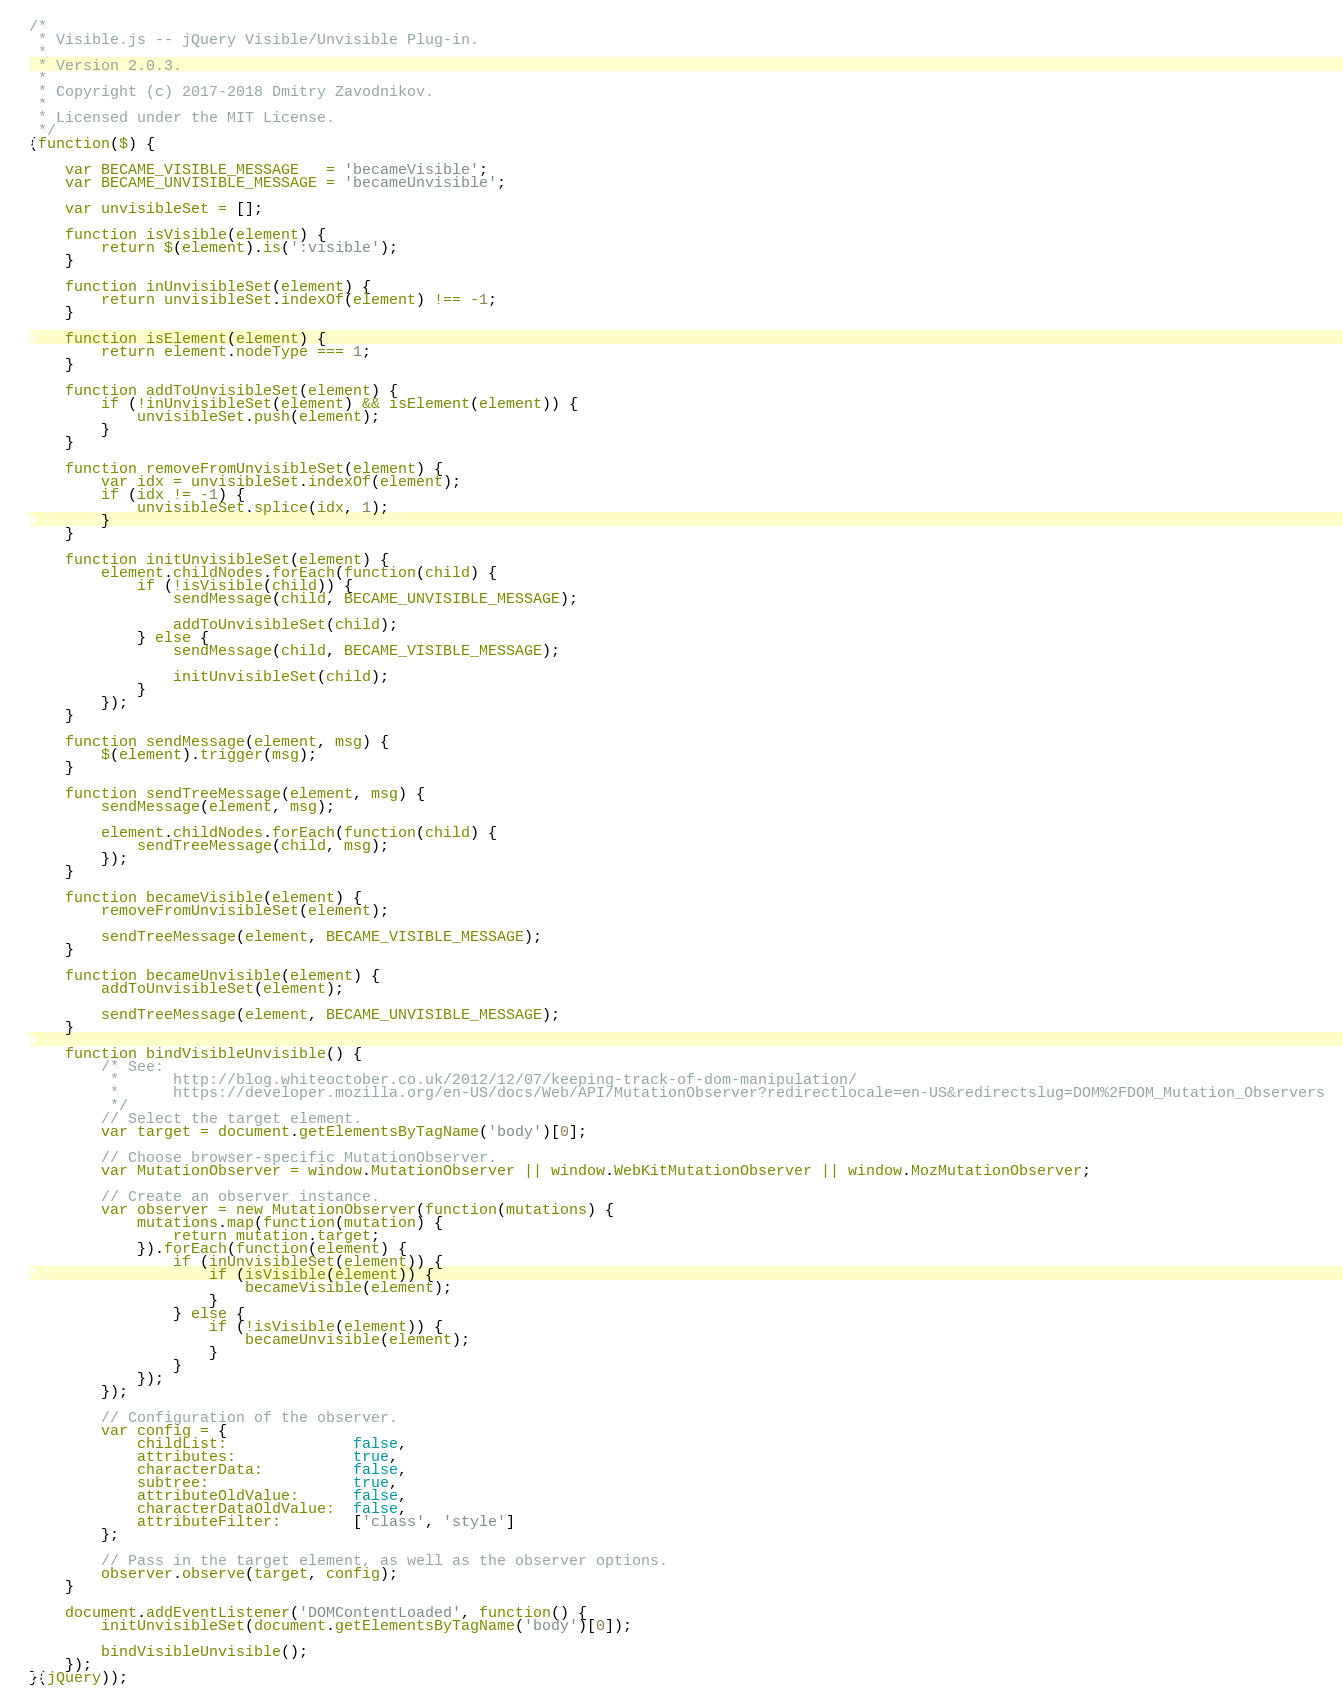<code> <loc_0><loc_0><loc_500><loc_500><_JavaScript_>/*
 * Visible.js -- jQuery Visible/Unvisible Plug-in.
 *
 * Version 2.0.3.
 *
 * Copyright (c) 2017-2018 Dmitry Zavodnikov.
 *
 * Licensed under the MIT License.
 */
(function($) {

    var BECAME_VISIBLE_MESSAGE   = 'becameVisible';
    var BECAME_UNVISIBLE_MESSAGE = 'becameUnvisible';

    var unvisibleSet = [];

    function isVisible(element) {
        return $(element).is(':visible');
    }

    function inUnvisibleSet(element) {
        return unvisibleSet.indexOf(element) !== -1;
    }

    function isElement(element) {
        return element.nodeType === 1;
    }

    function addToUnvisibleSet(element) {
        if (!inUnvisibleSet(element) && isElement(element)) {
            unvisibleSet.push(element);
        }
    }

    function removeFromUnvisibleSet(element) {
        var idx = unvisibleSet.indexOf(element);
        if (idx != -1) {
            unvisibleSet.splice(idx, 1);
        }
    }

    function initUnvisibleSet(element) {
        element.childNodes.forEach(function(child) {
            if (!isVisible(child)) {
                sendMessage(child, BECAME_UNVISIBLE_MESSAGE);

                addToUnvisibleSet(child);
            } else {
                sendMessage(child, BECAME_VISIBLE_MESSAGE);

                initUnvisibleSet(child);
            }
        });
    }

    function sendMessage(element, msg) {
        $(element).trigger(msg);
    }

    function sendTreeMessage(element, msg) {
        sendMessage(element, msg);

        element.childNodes.forEach(function(child) {
            sendTreeMessage(child, msg);
        });
    }

    function becameVisible(element) {
        removeFromUnvisibleSet(element);

        sendTreeMessage(element, BECAME_VISIBLE_MESSAGE);
    }

    function becameUnvisible(element) {
        addToUnvisibleSet(element);

        sendTreeMessage(element, BECAME_UNVISIBLE_MESSAGE);
    }

    function bindVisibleUnvisible() {
        /* See:
         *      http://blog.whiteoctober.co.uk/2012/12/07/keeping-track-of-dom-manipulation/
         *      https://developer.mozilla.org/en-US/docs/Web/API/MutationObserver?redirectlocale=en-US&redirectslug=DOM%2FDOM_Mutation_Observers
         */
        // Select the target element.
        var target = document.getElementsByTagName('body')[0];

        // Choose browser-specific MutationObserver.
        var MutationObserver = window.MutationObserver || window.WebKitMutationObserver || window.MozMutationObserver;

        // Create an observer instance.
        var observer = new MutationObserver(function(mutations) {
            mutations.map(function(mutation) {
                return mutation.target;
            }).forEach(function(element) {
                if (inUnvisibleSet(element)) {
                    if (isVisible(element)) {
                        becameVisible(element);
                    }
                } else {
                    if (!isVisible(element)) {
                        becameUnvisible(element);
                    }
                }
            });
        });

        // Configuration of the observer.
        var config = {
            childList:              false,
            attributes:             true,
            characterData:          false,
            subtree:                true,
            attributeOldValue:      false,
            characterDataOldValue:  false,
            attributeFilter:        ['class', 'style']
        };

        // Pass in the target element, as well as the observer options.
        observer.observe(target, config);
    }

    document.addEventListener('DOMContentLoaded', function() {
        initUnvisibleSet(document.getElementsByTagName('body')[0]);

        bindVisibleUnvisible();
    });
}(jQuery));
</code> 